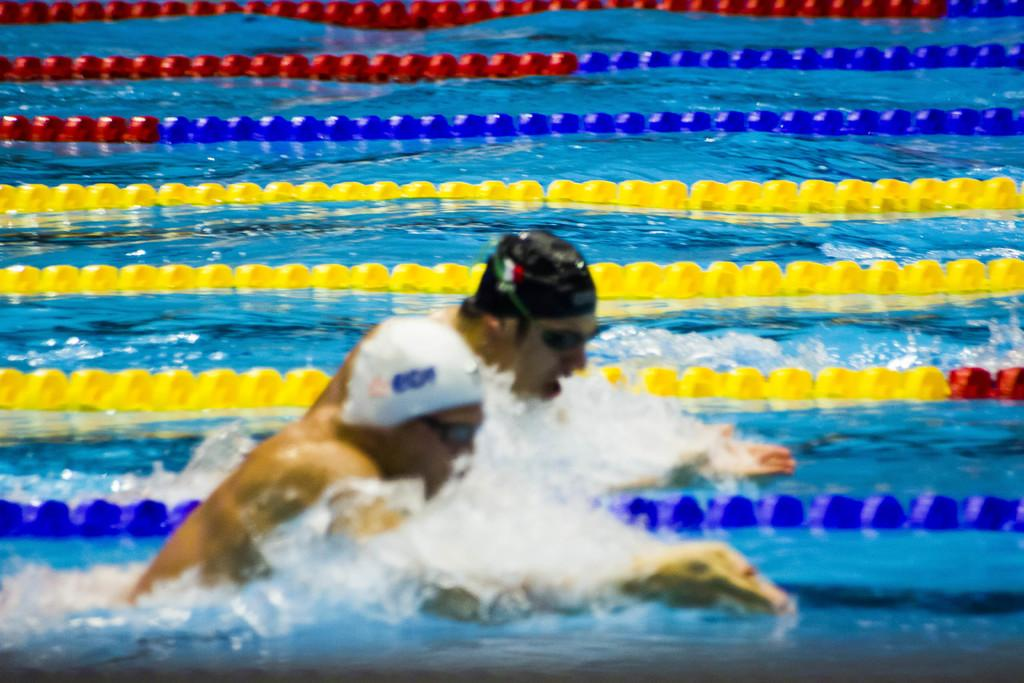What is the main feature of the image? There is a swimming pool in the image. What are the people in the image doing? Two people are swimming in the pool. Can you describe any additional objects or features in the pool? There are ribbon-like objects floating in the pool. What type of queen is sitting on the edge of the pool in the image? There is no queen present in the image; it features a swimming pool with two people swimming and ribbon-like objects floating in it. 